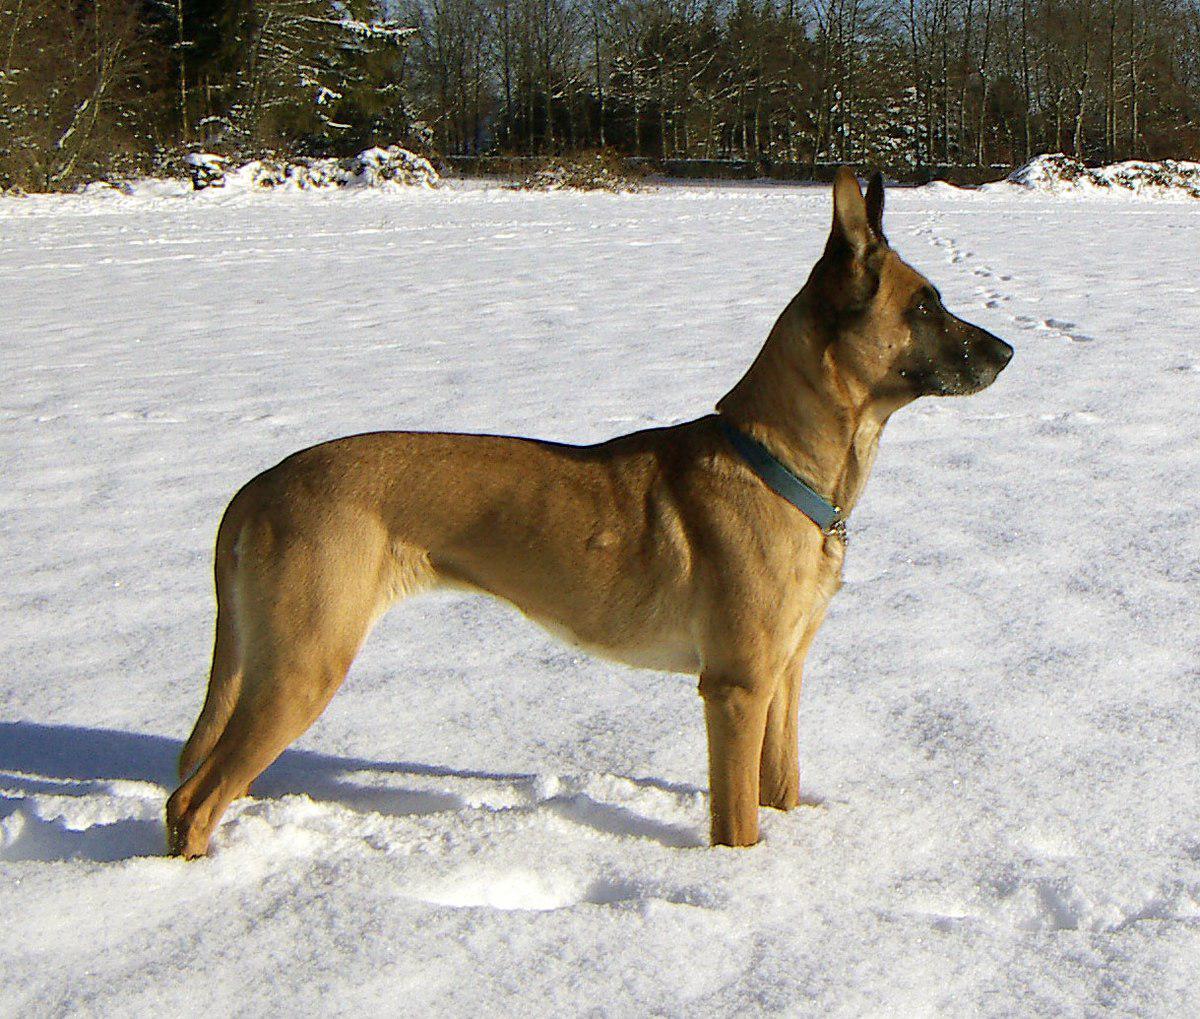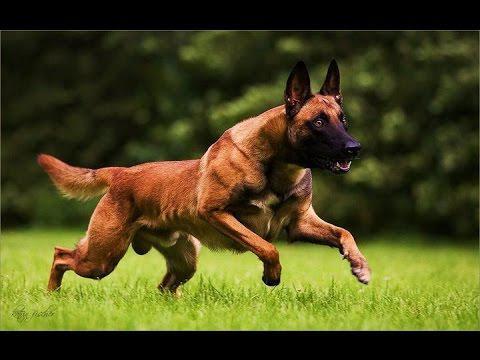The first image is the image on the left, the second image is the image on the right. For the images displayed, is the sentence "A dog is moving rightward across the grass, with at least two paws off the ground." factually correct? Answer yes or no. Yes. The first image is the image on the left, the second image is the image on the right. Given the left and right images, does the statement "In one of the images, a dog can be seen running in a green grassy area facing rightward." hold true? Answer yes or no. Yes. 